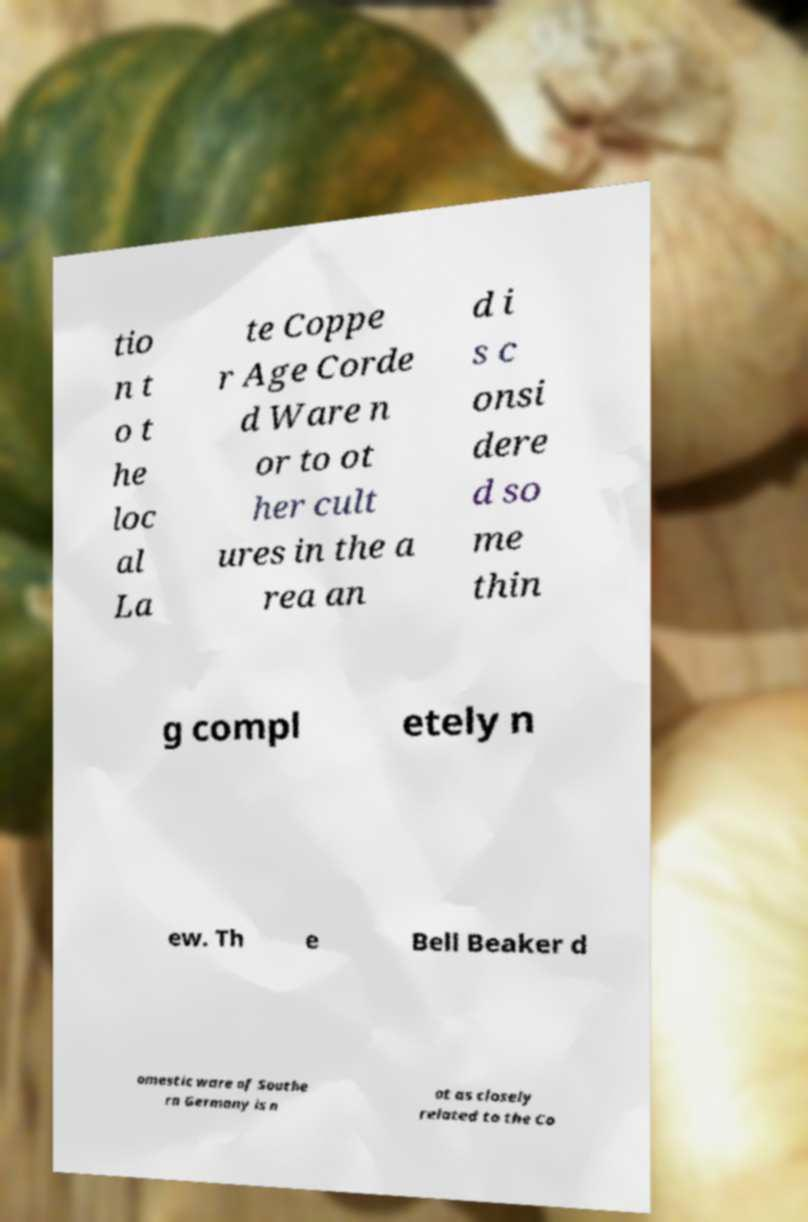Can you accurately transcribe the text from the provided image for me? tio n t o t he loc al La te Coppe r Age Corde d Ware n or to ot her cult ures in the a rea an d i s c onsi dere d so me thin g compl etely n ew. Th e Bell Beaker d omestic ware of Southe rn Germany is n ot as closely related to the Co 